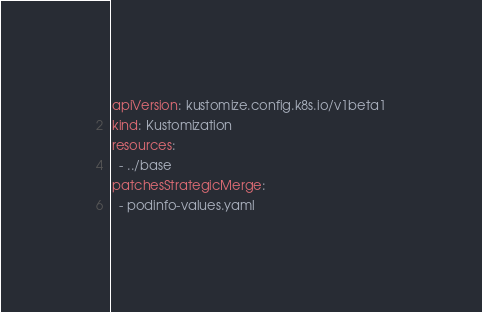Convert code to text. <code><loc_0><loc_0><loc_500><loc_500><_YAML_>apiVersion: kustomize.config.k8s.io/v1beta1
kind: Kustomization
resources:
  - ../base
patchesStrategicMerge:
  - podinfo-values.yaml
</code> 